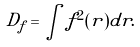Convert formula to latex. <formula><loc_0><loc_0><loc_500><loc_500>D _ { f } = \int f ^ { 2 } ( { r } ) d { r } .</formula> 